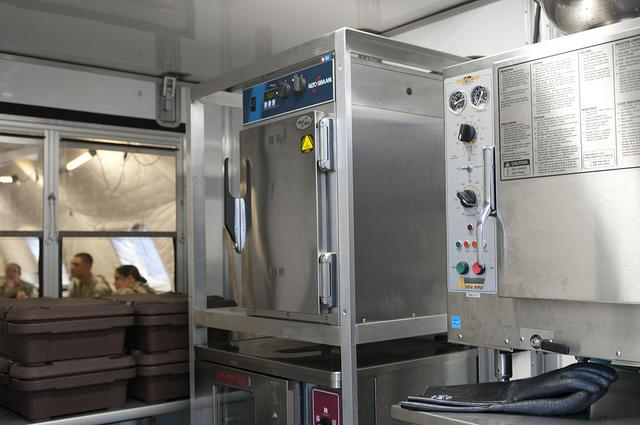What type of kitchen is this? industrial 